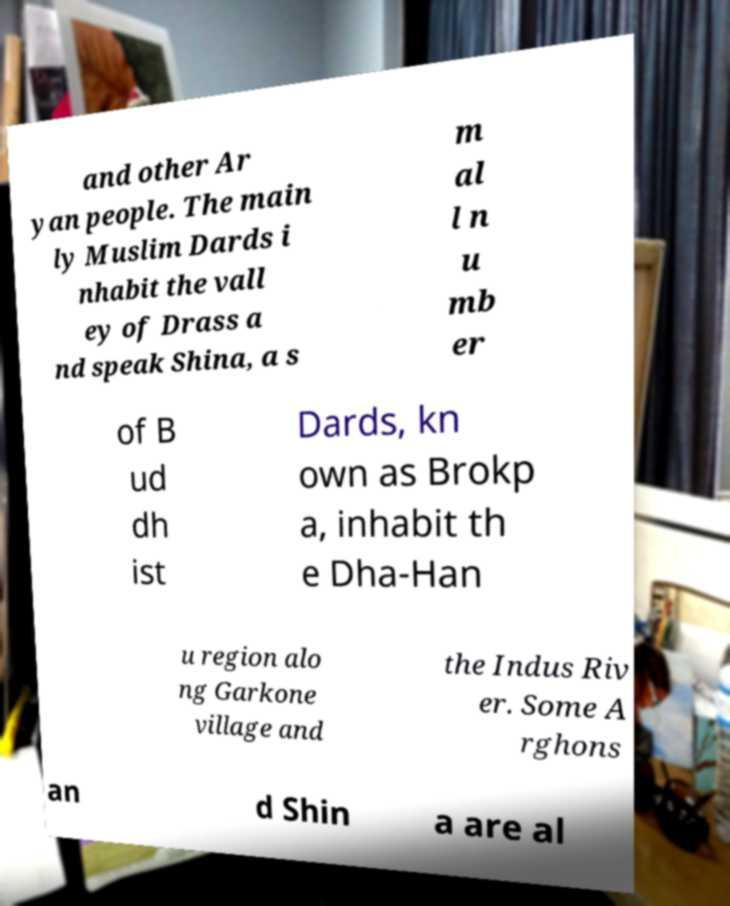Can you accurately transcribe the text from the provided image for me? and other Ar yan people. The main ly Muslim Dards i nhabit the vall ey of Drass a nd speak Shina, a s m al l n u mb er of B ud dh ist Dards, kn own as Brokp a, inhabit th e Dha-Han u region alo ng Garkone village and the Indus Riv er. Some A rghons an d Shin a are al 